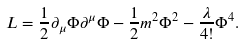<formula> <loc_0><loc_0><loc_500><loc_500>L = \frac { 1 } { 2 } \partial _ { \mu } \Phi \partial ^ { \mu } \Phi - \frac { 1 } { 2 } m ^ { 2 } \Phi ^ { 2 } - \frac { \lambda } { 4 ! } \Phi ^ { 4 } .</formula> 